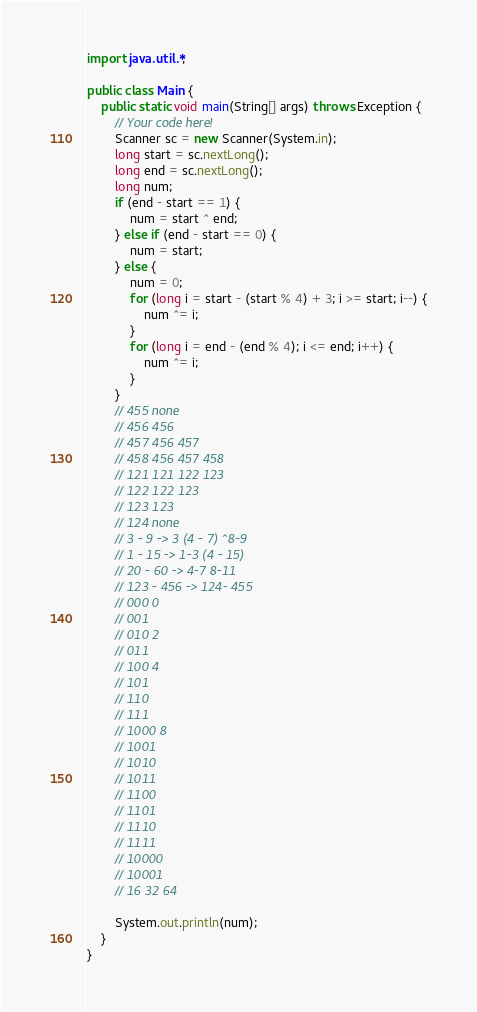Convert code to text. <code><loc_0><loc_0><loc_500><loc_500><_Java_>import java.util.*;

public class Main {
    public static void main(String[] args) throws Exception {
        // Your code here!
        Scanner sc = new Scanner(System.in);
        long start = sc.nextLong();
        long end = sc.nextLong();
        long num;
        if (end - start == 1) {
            num = start ^ end;
        } else if (end - start == 0) {
            num = start;
        } else {
            num = 0;
            for (long i = start - (start % 4) + 3; i >= start; i--) {
                num ^= i;
            }
            for (long i = end - (end % 4); i <= end; i++) {
                num ^= i;
            }
        }
        // 455 none
        // 456 456
        // 457 456 457
        // 458 456 457 458
        // 121 121 122 123
        // 122 122 123
        // 123 123
        // 124 none
        // 3 - 9 -> 3 (4 - 7) ^8-9
        // 1 - 15 -> 1-3 (4 - 15)
        // 20 - 60 -> 4-7 8-11
        // 123 - 456 -> 124- 455
        // 000 0
        // 001
        // 010 2
        // 011
        // 100 4
        // 101
        // 110
        // 111
        // 1000 8
        // 1001
        // 1010
        // 1011
        // 1100
        // 1101
        // 1110
        // 1111
        // 10000
        // 10001
        // 16 32 64
        
        System.out.println(num);
    }
}</code> 